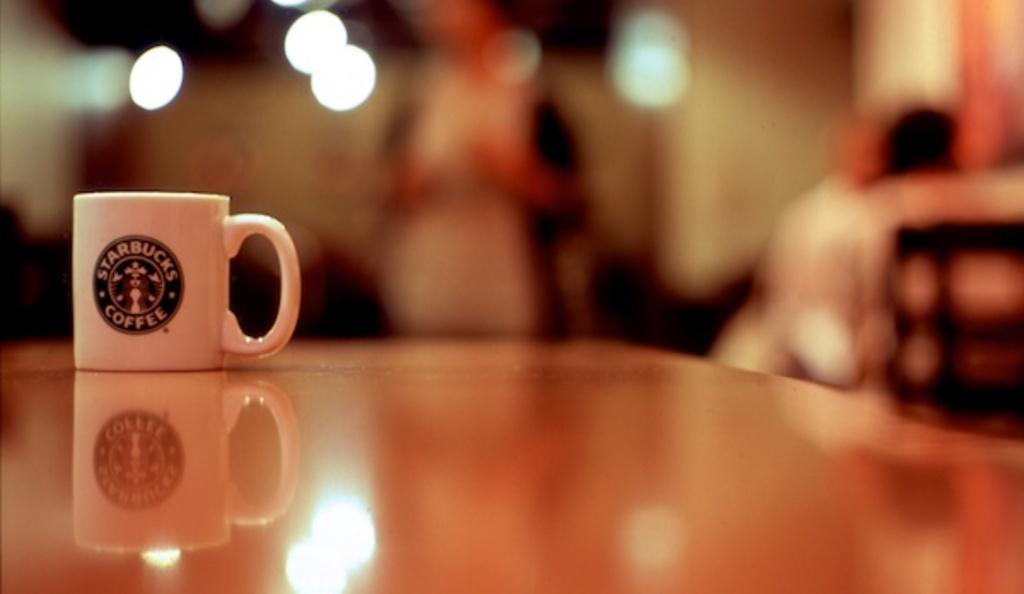In one or two sentences, can you explain what this image depicts? In the foreground of the picture there is a table, on the table there is a coffee cup. On the top right there is a chair and few persons seated. Background is blurry and there are lights and few people. 